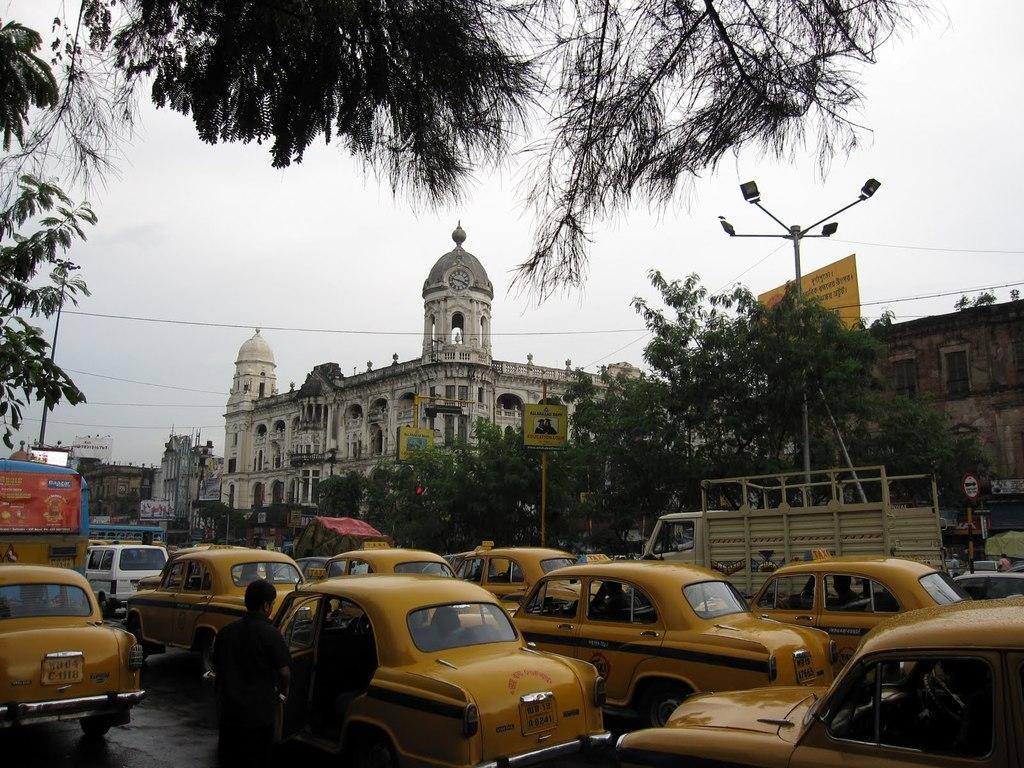What type of vehicles can be seen on the road in the image? There are yellow color taxis on the road in the image. What kind of building is present in the image? There is a white old building with a dome in the image. What type of vegetation can be seen in the image? There are trees visible in the image. How many dogs are sitting on the dome of the building in the image? There are no dogs present in the image; the focus is on the yellow taxis, the white old building with a dome, and the trees. 